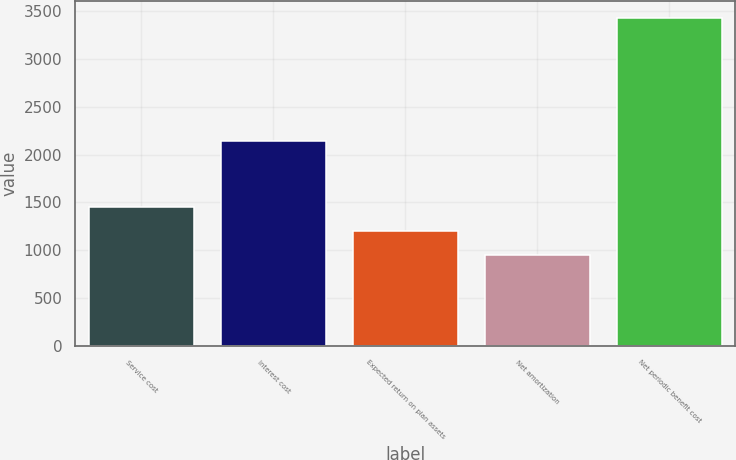<chart> <loc_0><loc_0><loc_500><loc_500><bar_chart><fcel>Service cost<fcel>Interest cost<fcel>Expected return on plan assets<fcel>Net amortization<fcel>Net periodic benefit cost<nl><fcel>1450.8<fcel>2146<fcel>1202.9<fcel>955<fcel>3434<nl></chart> 